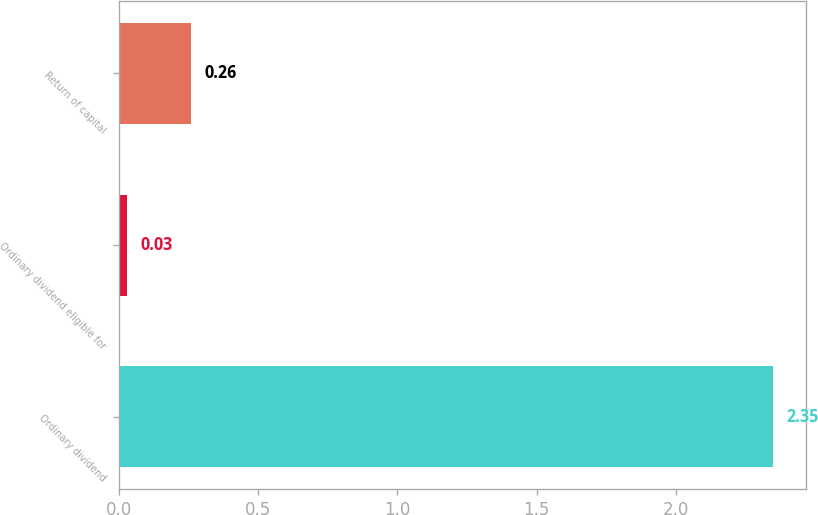Convert chart. <chart><loc_0><loc_0><loc_500><loc_500><bar_chart><fcel>Ordinary dividend<fcel>Ordinary dividend eligible for<fcel>Return of capital<nl><fcel>2.35<fcel>0.03<fcel>0.26<nl></chart> 